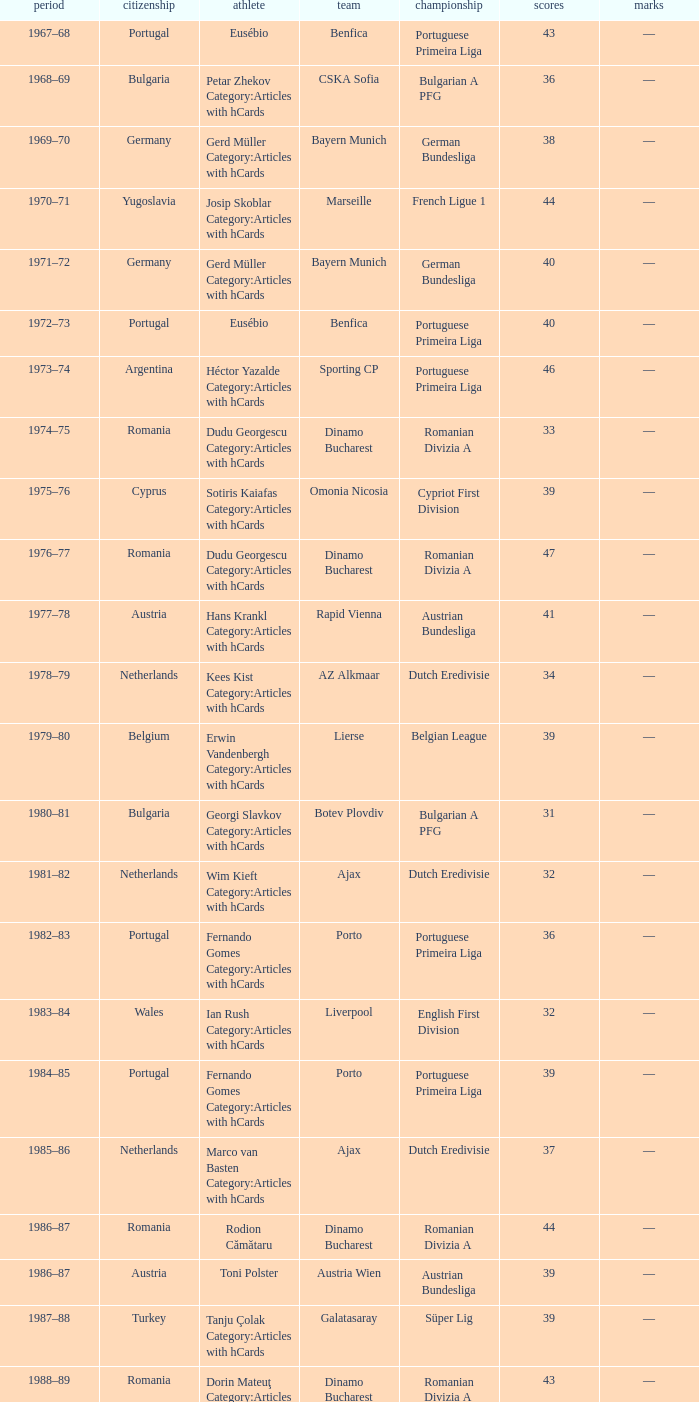Which league's nationality was Italy when there were 62 points? Italian Serie A. 